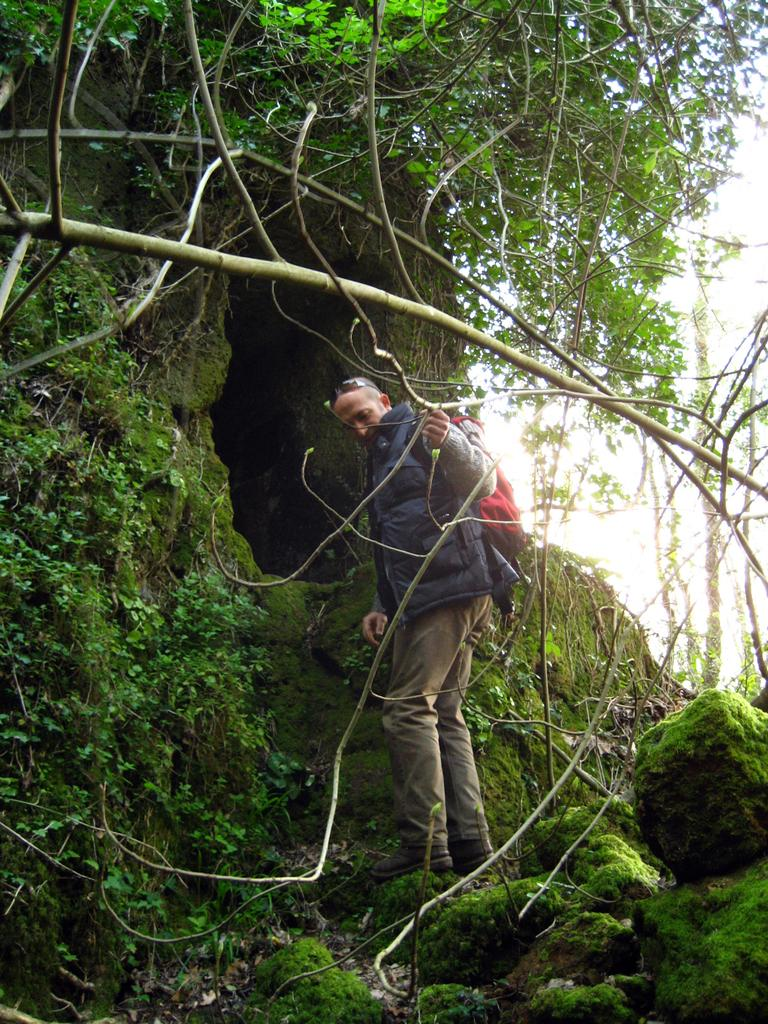Who or what is present in the image? There is a person in the image. What type of natural elements can be seen in the image? There are plants, trees, and stones in the image. What geological feature is visible in the image? There is a cave in the image. What part of the natural environment is visible in the image? The sky is visible in the image. How many pizzas are being served on the floor in the image? There are no pizzas or floors present in the image. 